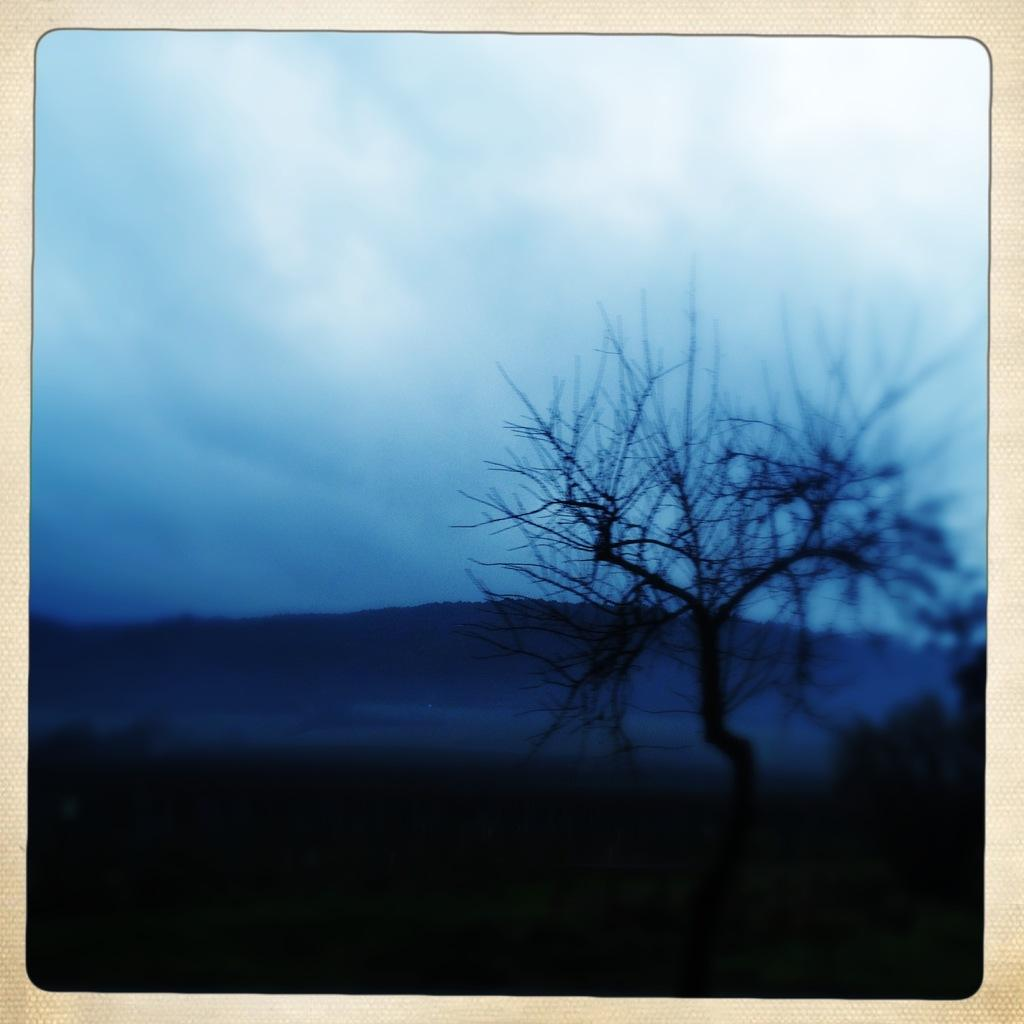What is the main feature of the image's borders? The image has borders, but we cannot determine their specific features from the given facts. What is located in the center of the image? There is a tree in the center of the image. What can be seen in the distance in the image? There are mountains in the background of the image. What type of vegetation is at the bottom of the image? There is grass at the bottom of the image. How many bricks are stacked on top of the tree in the image? There are no bricks present in the image; it features a tree, mountains, and grass. What type of mice can be seen running around the tree in the image? There are no mice present in the image; it features a tree, mountains, and grass. 